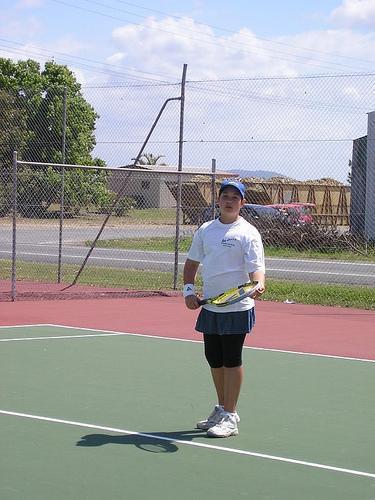How many elephants are in the image?
Give a very brief answer. 0. 